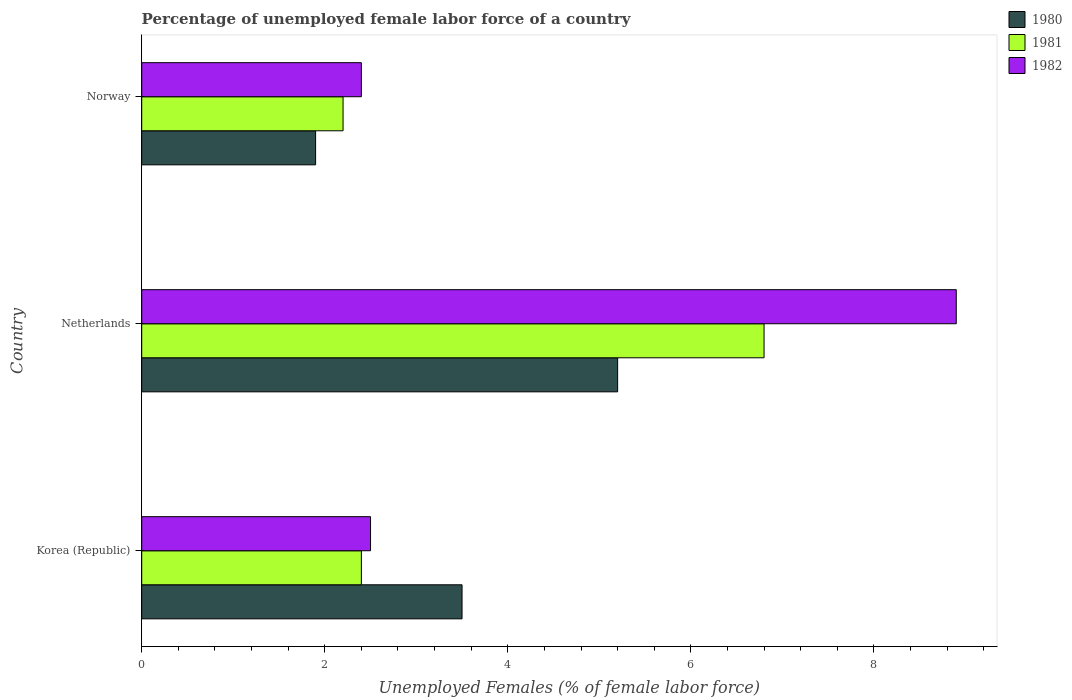How many different coloured bars are there?
Your answer should be compact. 3. Are the number of bars on each tick of the Y-axis equal?
Offer a very short reply. Yes. How many bars are there on the 1st tick from the top?
Make the answer very short. 3. What is the label of the 2nd group of bars from the top?
Give a very brief answer. Netherlands. What is the percentage of unemployed female labor force in 1981 in Netherlands?
Your response must be concise. 6.8. Across all countries, what is the maximum percentage of unemployed female labor force in 1982?
Provide a succinct answer. 8.9. Across all countries, what is the minimum percentage of unemployed female labor force in 1981?
Provide a succinct answer. 2.2. What is the total percentage of unemployed female labor force in 1980 in the graph?
Provide a succinct answer. 10.6. What is the difference between the percentage of unemployed female labor force in 1980 in Netherlands and that in Norway?
Give a very brief answer. 3.3. What is the difference between the percentage of unemployed female labor force in 1981 in Netherlands and the percentage of unemployed female labor force in 1982 in Norway?
Offer a very short reply. 4.4. What is the average percentage of unemployed female labor force in 1980 per country?
Make the answer very short. 3.53. What is the difference between the percentage of unemployed female labor force in 1980 and percentage of unemployed female labor force in 1981 in Netherlands?
Make the answer very short. -1.6. In how many countries, is the percentage of unemployed female labor force in 1981 greater than 8.4 %?
Your response must be concise. 0. What is the ratio of the percentage of unemployed female labor force in 1981 in Netherlands to that in Norway?
Your answer should be very brief. 3.09. Is the percentage of unemployed female labor force in 1980 in Netherlands less than that in Norway?
Offer a very short reply. No. What is the difference between the highest and the second highest percentage of unemployed female labor force in 1981?
Offer a very short reply. 4.4. What is the difference between the highest and the lowest percentage of unemployed female labor force in 1980?
Give a very brief answer. 3.3. Is the sum of the percentage of unemployed female labor force in 1980 in Korea (Republic) and Netherlands greater than the maximum percentage of unemployed female labor force in 1982 across all countries?
Ensure brevity in your answer.  No. Is it the case that in every country, the sum of the percentage of unemployed female labor force in 1980 and percentage of unemployed female labor force in 1982 is greater than the percentage of unemployed female labor force in 1981?
Offer a terse response. Yes. How many bars are there?
Your response must be concise. 9. What is the difference between two consecutive major ticks on the X-axis?
Make the answer very short. 2. Are the values on the major ticks of X-axis written in scientific E-notation?
Ensure brevity in your answer.  No. Does the graph contain any zero values?
Provide a succinct answer. No. Where does the legend appear in the graph?
Offer a terse response. Top right. What is the title of the graph?
Your answer should be compact. Percentage of unemployed female labor force of a country. Does "1960" appear as one of the legend labels in the graph?
Your answer should be compact. No. What is the label or title of the X-axis?
Offer a terse response. Unemployed Females (% of female labor force). What is the Unemployed Females (% of female labor force) in 1980 in Korea (Republic)?
Provide a succinct answer. 3.5. What is the Unemployed Females (% of female labor force) of 1981 in Korea (Republic)?
Your answer should be very brief. 2.4. What is the Unemployed Females (% of female labor force) in 1982 in Korea (Republic)?
Give a very brief answer. 2.5. What is the Unemployed Females (% of female labor force) in 1980 in Netherlands?
Provide a short and direct response. 5.2. What is the Unemployed Females (% of female labor force) of 1981 in Netherlands?
Your answer should be very brief. 6.8. What is the Unemployed Females (% of female labor force) of 1982 in Netherlands?
Offer a terse response. 8.9. What is the Unemployed Females (% of female labor force) of 1980 in Norway?
Provide a short and direct response. 1.9. What is the Unemployed Females (% of female labor force) in 1981 in Norway?
Give a very brief answer. 2.2. What is the Unemployed Females (% of female labor force) of 1982 in Norway?
Offer a very short reply. 2.4. Across all countries, what is the maximum Unemployed Females (% of female labor force) in 1980?
Provide a short and direct response. 5.2. Across all countries, what is the maximum Unemployed Females (% of female labor force) in 1981?
Offer a terse response. 6.8. Across all countries, what is the maximum Unemployed Females (% of female labor force) of 1982?
Provide a short and direct response. 8.9. Across all countries, what is the minimum Unemployed Females (% of female labor force) of 1980?
Your answer should be very brief. 1.9. Across all countries, what is the minimum Unemployed Females (% of female labor force) of 1981?
Provide a succinct answer. 2.2. Across all countries, what is the minimum Unemployed Females (% of female labor force) in 1982?
Your answer should be very brief. 2.4. What is the total Unemployed Females (% of female labor force) of 1981 in the graph?
Offer a terse response. 11.4. What is the total Unemployed Females (% of female labor force) of 1982 in the graph?
Your answer should be very brief. 13.8. What is the difference between the Unemployed Females (% of female labor force) in 1980 in Korea (Republic) and that in Netherlands?
Make the answer very short. -1.7. What is the difference between the Unemployed Females (% of female labor force) of 1982 in Korea (Republic) and that in Netherlands?
Provide a succinct answer. -6.4. What is the difference between the Unemployed Females (% of female labor force) of 1980 in Korea (Republic) and that in Norway?
Keep it short and to the point. 1.6. What is the difference between the Unemployed Females (% of female labor force) of 1982 in Korea (Republic) and that in Norway?
Your answer should be compact. 0.1. What is the difference between the Unemployed Females (% of female labor force) in 1980 in Netherlands and that in Norway?
Your response must be concise. 3.3. What is the difference between the Unemployed Females (% of female labor force) in 1981 in Netherlands and that in Norway?
Provide a succinct answer. 4.6. What is the difference between the Unemployed Females (% of female labor force) in 1980 in Korea (Republic) and the Unemployed Females (% of female labor force) in 1981 in Netherlands?
Provide a succinct answer. -3.3. What is the difference between the Unemployed Females (% of female labor force) of 1980 in Korea (Republic) and the Unemployed Females (% of female labor force) of 1982 in Netherlands?
Provide a short and direct response. -5.4. What is the difference between the Unemployed Females (% of female labor force) of 1980 in Korea (Republic) and the Unemployed Females (% of female labor force) of 1981 in Norway?
Your answer should be very brief. 1.3. What is the difference between the Unemployed Females (% of female labor force) of 1981 in Korea (Republic) and the Unemployed Females (% of female labor force) of 1982 in Norway?
Ensure brevity in your answer.  0. What is the difference between the Unemployed Females (% of female labor force) in 1980 in Netherlands and the Unemployed Females (% of female labor force) in 1981 in Norway?
Your answer should be very brief. 3. What is the difference between the Unemployed Females (% of female labor force) in 1980 in Netherlands and the Unemployed Females (% of female labor force) in 1982 in Norway?
Your answer should be compact. 2.8. What is the difference between the Unemployed Females (% of female labor force) in 1981 in Netherlands and the Unemployed Females (% of female labor force) in 1982 in Norway?
Offer a very short reply. 4.4. What is the average Unemployed Females (% of female labor force) of 1980 per country?
Ensure brevity in your answer.  3.53. What is the average Unemployed Females (% of female labor force) of 1981 per country?
Offer a very short reply. 3.8. What is the average Unemployed Females (% of female labor force) of 1982 per country?
Provide a succinct answer. 4.6. What is the difference between the Unemployed Females (% of female labor force) in 1980 and Unemployed Females (% of female labor force) in 1981 in Korea (Republic)?
Offer a terse response. 1.1. What is the difference between the Unemployed Females (% of female labor force) of 1980 and Unemployed Females (% of female labor force) of 1981 in Netherlands?
Give a very brief answer. -1.6. What is the difference between the Unemployed Females (% of female labor force) in 1980 and Unemployed Females (% of female labor force) in 1982 in Netherlands?
Make the answer very short. -3.7. What is the difference between the Unemployed Females (% of female labor force) of 1980 and Unemployed Females (% of female labor force) of 1981 in Norway?
Provide a short and direct response. -0.3. What is the difference between the Unemployed Females (% of female labor force) of 1980 and Unemployed Females (% of female labor force) of 1982 in Norway?
Your answer should be compact. -0.5. What is the ratio of the Unemployed Females (% of female labor force) in 1980 in Korea (Republic) to that in Netherlands?
Give a very brief answer. 0.67. What is the ratio of the Unemployed Females (% of female labor force) in 1981 in Korea (Republic) to that in Netherlands?
Offer a very short reply. 0.35. What is the ratio of the Unemployed Females (% of female labor force) in 1982 in Korea (Republic) to that in Netherlands?
Make the answer very short. 0.28. What is the ratio of the Unemployed Females (% of female labor force) in 1980 in Korea (Republic) to that in Norway?
Keep it short and to the point. 1.84. What is the ratio of the Unemployed Females (% of female labor force) of 1981 in Korea (Republic) to that in Norway?
Give a very brief answer. 1.09. What is the ratio of the Unemployed Females (% of female labor force) in 1982 in Korea (Republic) to that in Norway?
Your answer should be compact. 1.04. What is the ratio of the Unemployed Females (% of female labor force) of 1980 in Netherlands to that in Norway?
Provide a succinct answer. 2.74. What is the ratio of the Unemployed Females (% of female labor force) in 1981 in Netherlands to that in Norway?
Provide a succinct answer. 3.09. What is the ratio of the Unemployed Females (% of female labor force) in 1982 in Netherlands to that in Norway?
Your answer should be compact. 3.71. What is the difference between the highest and the second highest Unemployed Females (% of female labor force) of 1981?
Provide a short and direct response. 4.4. What is the difference between the highest and the lowest Unemployed Females (% of female labor force) in 1980?
Give a very brief answer. 3.3. 